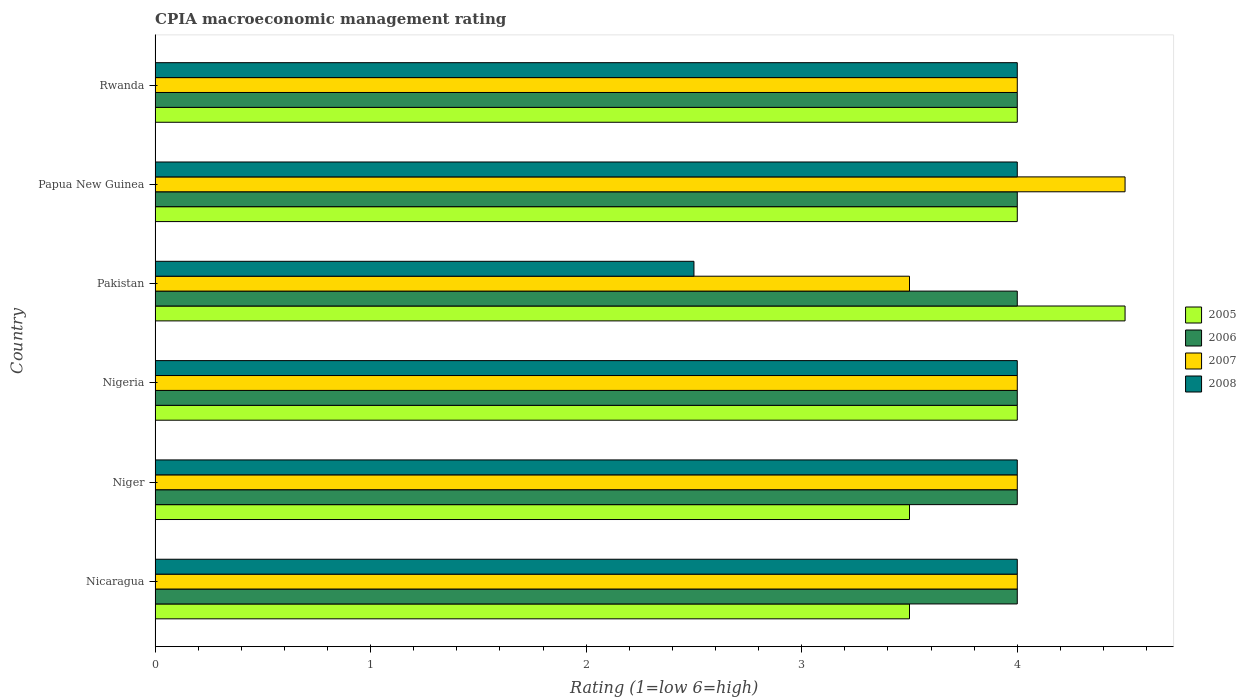How many groups of bars are there?
Offer a very short reply. 6. Are the number of bars per tick equal to the number of legend labels?
Provide a succinct answer. Yes. What is the label of the 5th group of bars from the top?
Provide a succinct answer. Niger. What is the CPIA rating in 2008 in Nicaragua?
Make the answer very short. 4. In which country was the CPIA rating in 2006 maximum?
Ensure brevity in your answer.  Nicaragua. What is the difference between the CPIA rating in 2008 in Nicaragua and that in Rwanda?
Your response must be concise. 0. What is the average CPIA rating in 2008 per country?
Your answer should be compact. 3.75. Is the CPIA rating in 2008 in Niger less than that in Pakistan?
Offer a very short reply. No. Is the difference between the CPIA rating in 2005 in Nicaragua and Niger greater than the difference between the CPIA rating in 2008 in Nicaragua and Niger?
Give a very brief answer. No. Is it the case that in every country, the sum of the CPIA rating in 2005 and CPIA rating in 2006 is greater than the sum of CPIA rating in 2008 and CPIA rating in 2007?
Provide a short and direct response. No. What does the 4th bar from the top in Nicaragua represents?
Your answer should be very brief. 2005. Is it the case that in every country, the sum of the CPIA rating in 2008 and CPIA rating in 2007 is greater than the CPIA rating in 2006?
Ensure brevity in your answer.  Yes. How many bars are there?
Ensure brevity in your answer.  24. Are all the bars in the graph horizontal?
Make the answer very short. Yes. How many countries are there in the graph?
Ensure brevity in your answer.  6. What is the difference between two consecutive major ticks on the X-axis?
Make the answer very short. 1. Does the graph contain any zero values?
Your response must be concise. No. Where does the legend appear in the graph?
Your answer should be very brief. Center right. How are the legend labels stacked?
Offer a very short reply. Vertical. What is the title of the graph?
Offer a terse response. CPIA macroeconomic management rating. What is the label or title of the X-axis?
Give a very brief answer. Rating (1=low 6=high). What is the label or title of the Y-axis?
Make the answer very short. Country. What is the Rating (1=low 6=high) of 2006 in Nicaragua?
Your response must be concise. 4. What is the Rating (1=low 6=high) in 2008 in Nicaragua?
Your answer should be compact. 4. What is the Rating (1=low 6=high) in 2005 in Niger?
Keep it short and to the point. 3.5. What is the Rating (1=low 6=high) in 2008 in Niger?
Ensure brevity in your answer.  4. What is the Rating (1=low 6=high) of 2005 in Nigeria?
Provide a succinct answer. 4. What is the Rating (1=low 6=high) of 2007 in Nigeria?
Give a very brief answer. 4. What is the Rating (1=low 6=high) in 2008 in Nigeria?
Ensure brevity in your answer.  4. What is the Rating (1=low 6=high) in 2008 in Pakistan?
Provide a short and direct response. 2.5. What is the Rating (1=low 6=high) of 2005 in Papua New Guinea?
Provide a short and direct response. 4. What is the Rating (1=low 6=high) in 2006 in Rwanda?
Offer a terse response. 4. What is the Rating (1=low 6=high) in 2007 in Rwanda?
Offer a terse response. 4. Across all countries, what is the maximum Rating (1=low 6=high) in 2007?
Your response must be concise. 4.5. Across all countries, what is the maximum Rating (1=low 6=high) in 2008?
Make the answer very short. 4. Across all countries, what is the minimum Rating (1=low 6=high) of 2005?
Offer a very short reply. 3.5. Across all countries, what is the minimum Rating (1=low 6=high) in 2006?
Offer a very short reply. 4. Across all countries, what is the minimum Rating (1=low 6=high) of 2008?
Provide a short and direct response. 2.5. What is the total Rating (1=low 6=high) of 2005 in the graph?
Ensure brevity in your answer.  23.5. What is the total Rating (1=low 6=high) in 2007 in the graph?
Provide a succinct answer. 24. What is the difference between the Rating (1=low 6=high) in 2006 in Nicaragua and that in Niger?
Your answer should be compact. 0. What is the difference between the Rating (1=low 6=high) in 2007 in Nicaragua and that in Niger?
Your answer should be very brief. 0. What is the difference between the Rating (1=low 6=high) in 2007 in Nicaragua and that in Nigeria?
Give a very brief answer. 0. What is the difference between the Rating (1=low 6=high) in 2008 in Nicaragua and that in Nigeria?
Provide a short and direct response. 0. What is the difference between the Rating (1=low 6=high) of 2005 in Nicaragua and that in Pakistan?
Make the answer very short. -1. What is the difference between the Rating (1=low 6=high) in 2006 in Nicaragua and that in Pakistan?
Your answer should be very brief. 0. What is the difference between the Rating (1=low 6=high) in 2007 in Nicaragua and that in Pakistan?
Provide a short and direct response. 0.5. What is the difference between the Rating (1=low 6=high) in 2005 in Nicaragua and that in Papua New Guinea?
Your answer should be compact. -0.5. What is the difference between the Rating (1=low 6=high) of 2006 in Nicaragua and that in Papua New Guinea?
Provide a short and direct response. 0. What is the difference between the Rating (1=low 6=high) in 2008 in Nicaragua and that in Papua New Guinea?
Ensure brevity in your answer.  0. What is the difference between the Rating (1=low 6=high) in 2006 in Nicaragua and that in Rwanda?
Offer a very short reply. 0. What is the difference between the Rating (1=low 6=high) of 2007 in Nicaragua and that in Rwanda?
Provide a succinct answer. 0. What is the difference between the Rating (1=low 6=high) of 2008 in Nicaragua and that in Rwanda?
Your response must be concise. 0. What is the difference between the Rating (1=low 6=high) of 2006 in Niger and that in Nigeria?
Make the answer very short. 0. What is the difference between the Rating (1=low 6=high) of 2006 in Niger and that in Pakistan?
Offer a terse response. 0. What is the difference between the Rating (1=low 6=high) in 2007 in Niger and that in Pakistan?
Keep it short and to the point. 0.5. What is the difference between the Rating (1=low 6=high) in 2005 in Niger and that in Papua New Guinea?
Offer a very short reply. -0.5. What is the difference between the Rating (1=low 6=high) of 2008 in Niger and that in Rwanda?
Give a very brief answer. 0. What is the difference between the Rating (1=low 6=high) in 2005 in Nigeria and that in Pakistan?
Your answer should be compact. -0.5. What is the difference between the Rating (1=low 6=high) of 2005 in Nigeria and that in Papua New Guinea?
Ensure brevity in your answer.  0. What is the difference between the Rating (1=low 6=high) of 2008 in Nigeria and that in Papua New Guinea?
Ensure brevity in your answer.  0. What is the difference between the Rating (1=low 6=high) of 2006 in Nigeria and that in Rwanda?
Offer a very short reply. 0. What is the difference between the Rating (1=low 6=high) in 2006 in Pakistan and that in Papua New Guinea?
Offer a terse response. 0. What is the difference between the Rating (1=low 6=high) in 2008 in Pakistan and that in Papua New Guinea?
Your answer should be very brief. -1.5. What is the difference between the Rating (1=low 6=high) of 2005 in Pakistan and that in Rwanda?
Your response must be concise. 0.5. What is the difference between the Rating (1=low 6=high) of 2006 in Papua New Guinea and that in Rwanda?
Give a very brief answer. 0. What is the difference between the Rating (1=low 6=high) of 2007 in Papua New Guinea and that in Rwanda?
Offer a terse response. 0.5. What is the difference between the Rating (1=low 6=high) of 2005 in Nicaragua and the Rating (1=low 6=high) of 2006 in Niger?
Offer a terse response. -0.5. What is the difference between the Rating (1=low 6=high) in 2005 in Nicaragua and the Rating (1=low 6=high) in 2007 in Niger?
Provide a succinct answer. -0.5. What is the difference between the Rating (1=low 6=high) in 2005 in Nicaragua and the Rating (1=low 6=high) in 2008 in Niger?
Your response must be concise. -0.5. What is the difference between the Rating (1=low 6=high) in 2005 in Nicaragua and the Rating (1=low 6=high) in 2006 in Nigeria?
Make the answer very short. -0.5. What is the difference between the Rating (1=low 6=high) of 2006 in Nicaragua and the Rating (1=low 6=high) of 2007 in Pakistan?
Provide a succinct answer. 0.5. What is the difference between the Rating (1=low 6=high) of 2006 in Nicaragua and the Rating (1=low 6=high) of 2007 in Papua New Guinea?
Offer a terse response. -0.5. What is the difference between the Rating (1=low 6=high) in 2005 in Nicaragua and the Rating (1=low 6=high) in 2006 in Rwanda?
Provide a short and direct response. -0.5. What is the difference between the Rating (1=low 6=high) of 2006 in Nicaragua and the Rating (1=low 6=high) of 2008 in Rwanda?
Keep it short and to the point. 0. What is the difference between the Rating (1=low 6=high) in 2006 in Niger and the Rating (1=low 6=high) in 2007 in Nigeria?
Provide a succinct answer. 0. What is the difference between the Rating (1=low 6=high) in 2005 in Niger and the Rating (1=low 6=high) in 2007 in Pakistan?
Make the answer very short. 0. What is the difference between the Rating (1=low 6=high) in 2005 in Niger and the Rating (1=low 6=high) in 2008 in Pakistan?
Keep it short and to the point. 1. What is the difference between the Rating (1=low 6=high) in 2005 in Niger and the Rating (1=low 6=high) in 2006 in Papua New Guinea?
Your answer should be very brief. -0.5. What is the difference between the Rating (1=low 6=high) in 2005 in Niger and the Rating (1=low 6=high) in 2007 in Papua New Guinea?
Offer a terse response. -1. What is the difference between the Rating (1=low 6=high) of 2007 in Niger and the Rating (1=low 6=high) of 2008 in Papua New Guinea?
Your response must be concise. 0. What is the difference between the Rating (1=low 6=high) of 2005 in Niger and the Rating (1=low 6=high) of 2006 in Rwanda?
Your answer should be very brief. -0.5. What is the difference between the Rating (1=low 6=high) of 2005 in Niger and the Rating (1=low 6=high) of 2007 in Rwanda?
Offer a terse response. -0.5. What is the difference between the Rating (1=low 6=high) in 2005 in Niger and the Rating (1=low 6=high) in 2008 in Rwanda?
Offer a terse response. -0.5. What is the difference between the Rating (1=low 6=high) of 2005 in Nigeria and the Rating (1=low 6=high) of 2007 in Pakistan?
Your response must be concise. 0.5. What is the difference between the Rating (1=low 6=high) in 2005 in Nigeria and the Rating (1=low 6=high) in 2006 in Papua New Guinea?
Ensure brevity in your answer.  0. What is the difference between the Rating (1=low 6=high) of 2005 in Nigeria and the Rating (1=low 6=high) of 2008 in Papua New Guinea?
Give a very brief answer. 0. What is the difference between the Rating (1=low 6=high) of 2007 in Nigeria and the Rating (1=low 6=high) of 2008 in Papua New Guinea?
Give a very brief answer. 0. What is the difference between the Rating (1=low 6=high) of 2006 in Nigeria and the Rating (1=low 6=high) of 2008 in Rwanda?
Make the answer very short. 0. What is the difference between the Rating (1=low 6=high) in 2005 in Pakistan and the Rating (1=low 6=high) in 2007 in Papua New Guinea?
Your response must be concise. 0. What is the difference between the Rating (1=low 6=high) of 2005 in Pakistan and the Rating (1=low 6=high) of 2008 in Papua New Guinea?
Keep it short and to the point. 0.5. What is the difference between the Rating (1=low 6=high) of 2006 in Pakistan and the Rating (1=low 6=high) of 2007 in Papua New Guinea?
Your answer should be very brief. -0.5. What is the difference between the Rating (1=low 6=high) of 2006 in Pakistan and the Rating (1=low 6=high) of 2008 in Papua New Guinea?
Keep it short and to the point. 0. What is the difference between the Rating (1=low 6=high) of 2005 in Pakistan and the Rating (1=low 6=high) of 2007 in Rwanda?
Make the answer very short. 0.5. What is the difference between the Rating (1=low 6=high) of 2005 in Pakistan and the Rating (1=low 6=high) of 2008 in Rwanda?
Provide a succinct answer. 0.5. What is the difference between the Rating (1=low 6=high) of 2006 in Pakistan and the Rating (1=low 6=high) of 2008 in Rwanda?
Offer a very short reply. 0. What is the difference between the Rating (1=low 6=high) of 2006 in Papua New Guinea and the Rating (1=low 6=high) of 2007 in Rwanda?
Your answer should be very brief. 0. What is the difference between the Rating (1=low 6=high) in 2006 in Papua New Guinea and the Rating (1=low 6=high) in 2008 in Rwanda?
Provide a short and direct response. 0. What is the average Rating (1=low 6=high) in 2005 per country?
Provide a succinct answer. 3.92. What is the average Rating (1=low 6=high) in 2006 per country?
Provide a short and direct response. 4. What is the average Rating (1=low 6=high) in 2008 per country?
Make the answer very short. 3.75. What is the difference between the Rating (1=low 6=high) in 2007 and Rating (1=low 6=high) in 2008 in Nicaragua?
Your answer should be compact. 0. What is the difference between the Rating (1=low 6=high) of 2005 and Rating (1=low 6=high) of 2007 in Niger?
Provide a succinct answer. -0.5. What is the difference between the Rating (1=low 6=high) in 2006 and Rating (1=low 6=high) in 2007 in Niger?
Keep it short and to the point. 0. What is the difference between the Rating (1=low 6=high) of 2007 and Rating (1=low 6=high) of 2008 in Niger?
Provide a succinct answer. 0. What is the difference between the Rating (1=low 6=high) in 2005 and Rating (1=low 6=high) in 2006 in Nigeria?
Provide a succinct answer. 0. What is the difference between the Rating (1=low 6=high) in 2006 and Rating (1=low 6=high) in 2007 in Nigeria?
Make the answer very short. 0. What is the difference between the Rating (1=low 6=high) of 2005 and Rating (1=low 6=high) of 2006 in Pakistan?
Ensure brevity in your answer.  0.5. What is the difference between the Rating (1=low 6=high) of 2005 and Rating (1=low 6=high) of 2007 in Pakistan?
Ensure brevity in your answer.  1. What is the difference between the Rating (1=low 6=high) of 2006 and Rating (1=low 6=high) of 2007 in Pakistan?
Offer a terse response. 0.5. What is the difference between the Rating (1=low 6=high) in 2006 and Rating (1=low 6=high) in 2008 in Pakistan?
Your response must be concise. 1.5. What is the difference between the Rating (1=low 6=high) of 2007 and Rating (1=low 6=high) of 2008 in Pakistan?
Provide a succinct answer. 1. What is the difference between the Rating (1=low 6=high) of 2005 and Rating (1=low 6=high) of 2008 in Papua New Guinea?
Offer a very short reply. 0. What is the difference between the Rating (1=low 6=high) of 2006 and Rating (1=low 6=high) of 2008 in Papua New Guinea?
Provide a succinct answer. 0. What is the difference between the Rating (1=low 6=high) in 2007 and Rating (1=low 6=high) in 2008 in Papua New Guinea?
Give a very brief answer. 0.5. What is the difference between the Rating (1=low 6=high) of 2005 and Rating (1=low 6=high) of 2007 in Rwanda?
Offer a terse response. 0. What is the difference between the Rating (1=low 6=high) in 2006 and Rating (1=low 6=high) in 2008 in Rwanda?
Your answer should be very brief. 0. What is the ratio of the Rating (1=low 6=high) of 2006 in Nicaragua to that in Niger?
Provide a short and direct response. 1. What is the ratio of the Rating (1=low 6=high) in 2006 in Nicaragua to that in Nigeria?
Offer a very short reply. 1. What is the ratio of the Rating (1=low 6=high) of 2007 in Nicaragua to that in Nigeria?
Your answer should be compact. 1. What is the ratio of the Rating (1=low 6=high) of 2008 in Nicaragua to that in Nigeria?
Provide a short and direct response. 1. What is the ratio of the Rating (1=low 6=high) of 2007 in Nicaragua to that in Pakistan?
Ensure brevity in your answer.  1.14. What is the ratio of the Rating (1=low 6=high) in 2005 in Nicaragua to that in Papua New Guinea?
Your answer should be compact. 0.88. What is the ratio of the Rating (1=low 6=high) in 2008 in Nicaragua to that in Papua New Guinea?
Your answer should be very brief. 1. What is the ratio of the Rating (1=low 6=high) in 2006 in Nicaragua to that in Rwanda?
Give a very brief answer. 1. What is the ratio of the Rating (1=low 6=high) of 2008 in Nicaragua to that in Rwanda?
Give a very brief answer. 1. What is the ratio of the Rating (1=low 6=high) of 2006 in Niger to that in Nigeria?
Offer a terse response. 1. What is the ratio of the Rating (1=low 6=high) in 2005 in Niger to that in Pakistan?
Offer a terse response. 0.78. What is the ratio of the Rating (1=low 6=high) of 2006 in Niger to that in Pakistan?
Ensure brevity in your answer.  1. What is the ratio of the Rating (1=low 6=high) in 2007 in Niger to that in Pakistan?
Offer a terse response. 1.14. What is the ratio of the Rating (1=low 6=high) of 2008 in Niger to that in Pakistan?
Your answer should be very brief. 1.6. What is the ratio of the Rating (1=low 6=high) in 2005 in Niger to that in Papua New Guinea?
Make the answer very short. 0.88. What is the ratio of the Rating (1=low 6=high) of 2006 in Niger to that in Papua New Guinea?
Make the answer very short. 1. What is the ratio of the Rating (1=low 6=high) in 2005 in Niger to that in Rwanda?
Provide a short and direct response. 0.88. What is the ratio of the Rating (1=low 6=high) of 2006 in Niger to that in Rwanda?
Provide a succinct answer. 1. What is the ratio of the Rating (1=low 6=high) of 2007 in Niger to that in Rwanda?
Your response must be concise. 1. What is the ratio of the Rating (1=low 6=high) in 2008 in Niger to that in Rwanda?
Provide a short and direct response. 1. What is the ratio of the Rating (1=low 6=high) in 2007 in Nigeria to that in Pakistan?
Provide a short and direct response. 1.14. What is the ratio of the Rating (1=low 6=high) in 2008 in Nigeria to that in Pakistan?
Offer a terse response. 1.6. What is the ratio of the Rating (1=low 6=high) in 2006 in Nigeria to that in Papua New Guinea?
Your response must be concise. 1. What is the ratio of the Rating (1=low 6=high) of 2007 in Nigeria to that in Papua New Guinea?
Provide a succinct answer. 0.89. What is the ratio of the Rating (1=low 6=high) of 2005 in Nigeria to that in Rwanda?
Keep it short and to the point. 1. What is the ratio of the Rating (1=low 6=high) of 2006 in Nigeria to that in Rwanda?
Your answer should be very brief. 1. What is the ratio of the Rating (1=low 6=high) of 2008 in Nigeria to that in Rwanda?
Offer a very short reply. 1. What is the ratio of the Rating (1=low 6=high) of 2005 in Pakistan to that in Papua New Guinea?
Keep it short and to the point. 1.12. What is the ratio of the Rating (1=low 6=high) of 2006 in Pakistan to that in Papua New Guinea?
Keep it short and to the point. 1. What is the ratio of the Rating (1=low 6=high) in 2005 in Pakistan to that in Rwanda?
Give a very brief answer. 1.12. What is the ratio of the Rating (1=low 6=high) of 2006 in Pakistan to that in Rwanda?
Your response must be concise. 1. What is the ratio of the Rating (1=low 6=high) of 2008 in Pakistan to that in Rwanda?
Offer a terse response. 0.62. What is the ratio of the Rating (1=low 6=high) in 2005 in Papua New Guinea to that in Rwanda?
Provide a succinct answer. 1. What is the ratio of the Rating (1=low 6=high) of 2007 in Papua New Guinea to that in Rwanda?
Provide a succinct answer. 1.12. What is the difference between the highest and the second highest Rating (1=low 6=high) in 2005?
Offer a terse response. 0.5. What is the difference between the highest and the second highest Rating (1=low 6=high) of 2008?
Offer a very short reply. 0. What is the difference between the highest and the lowest Rating (1=low 6=high) of 2006?
Provide a succinct answer. 0. What is the difference between the highest and the lowest Rating (1=low 6=high) in 2007?
Your answer should be very brief. 1. 